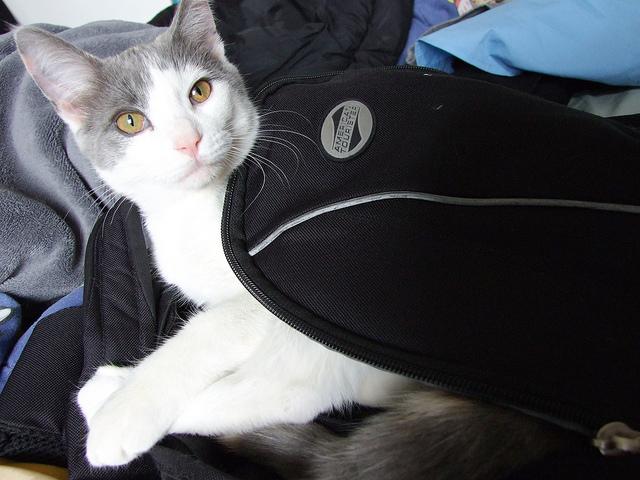What color is that jacket?
Quick response, please. Black. What is the cat wearing?
Give a very brief answer. Jacket. What color is the cat's eyes?
Quick response, please. Yellow. What is the cat inside of?
Concise answer only. Backpack. Is the cat happy?
Keep it brief. Yes. Is the cat sleepy?
Short answer required. No. Is this cat annoyed with the camera person?
Answer briefly. Yes. 